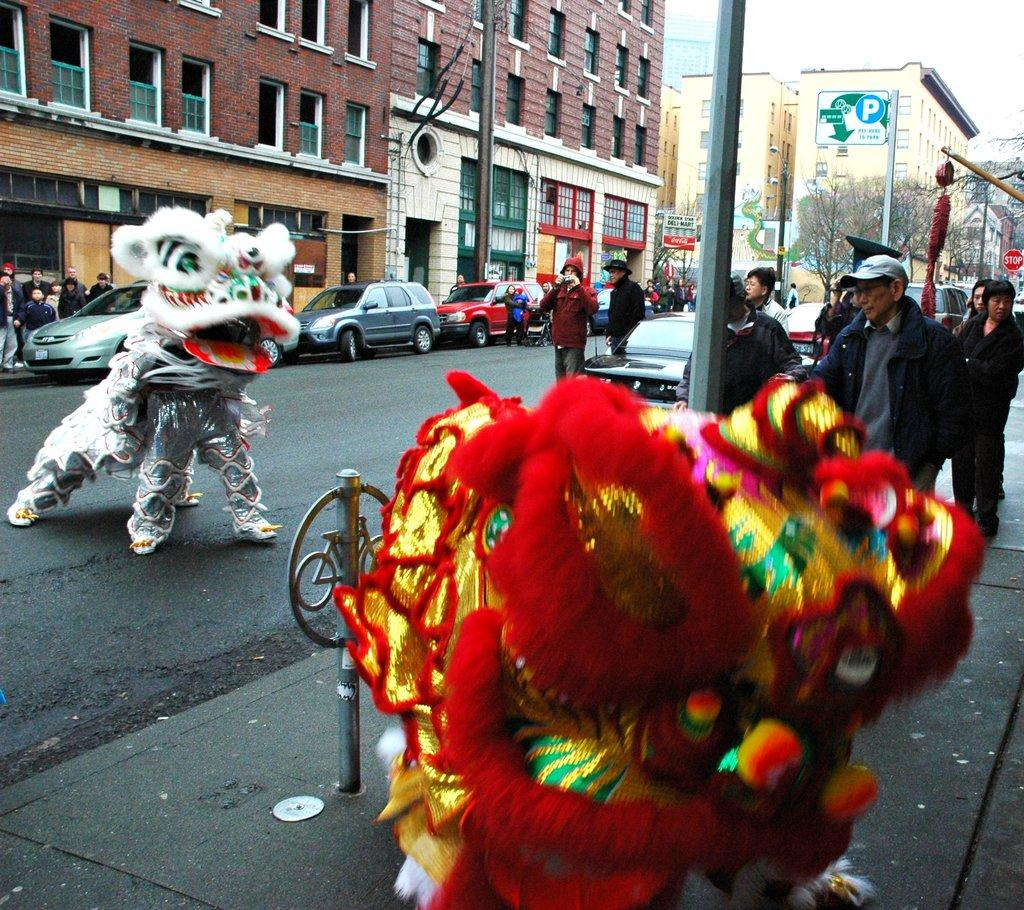What type of structures can be seen in the image? There are houses in the image. What other natural elements are present in the image? There are trees in the image. What type of traffic control devices are visible in the image? There are traffic signals in the image. Are there any living beings in the image? Yes, there are people in the image. What type of vehicles can be seen in the image? There are cars in the image. What kind of signage is present in the image? There is a sign board in the image. What part of the natural environment is visible in the image? The sky is visible in the image. Can you tell me how many hens are depicted on the sign board in the image? There are no hens present on the sign board or in the image; it features traffic and road-related information. What type of berry can be seen growing on the trees in the image? There is no mention of berries or any specific type of fruit growing on the trees in the image; the trees are not described in detail. 